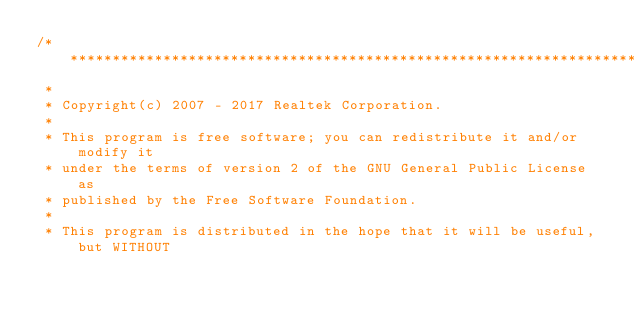<code> <loc_0><loc_0><loc_500><loc_500><_C_>/******************************************************************************
 *
 * Copyright(c) 2007 - 2017 Realtek Corporation.
 *
 * This program is free software; you can redistribute it and/or modify it
 * under the terms of version 2 of the GNU General Public License as
 * published by the Free Software Foundation.
 *
 * This program is distributed in the hope that it will be useful, but WITHOUT</code> 